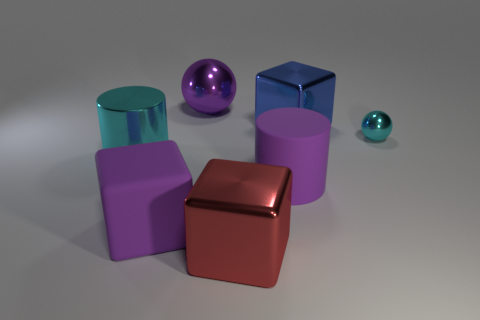Add 1 tiny green shiny balls. How many objects exist? 8 Subtract all purple blocks. How many blocks are left? 2 Subtract all blocks. How many objects are left? 4 Add 4 red spheres. How many red spheres exist? 4 Subtract 0 blue balls. How many objects are left? 7 Subtract all large cyan things. Subtract all large red metallic cubes. How many objects are left? 5 Add 3 large metallic balls. How many large metallic balls are left? 4 